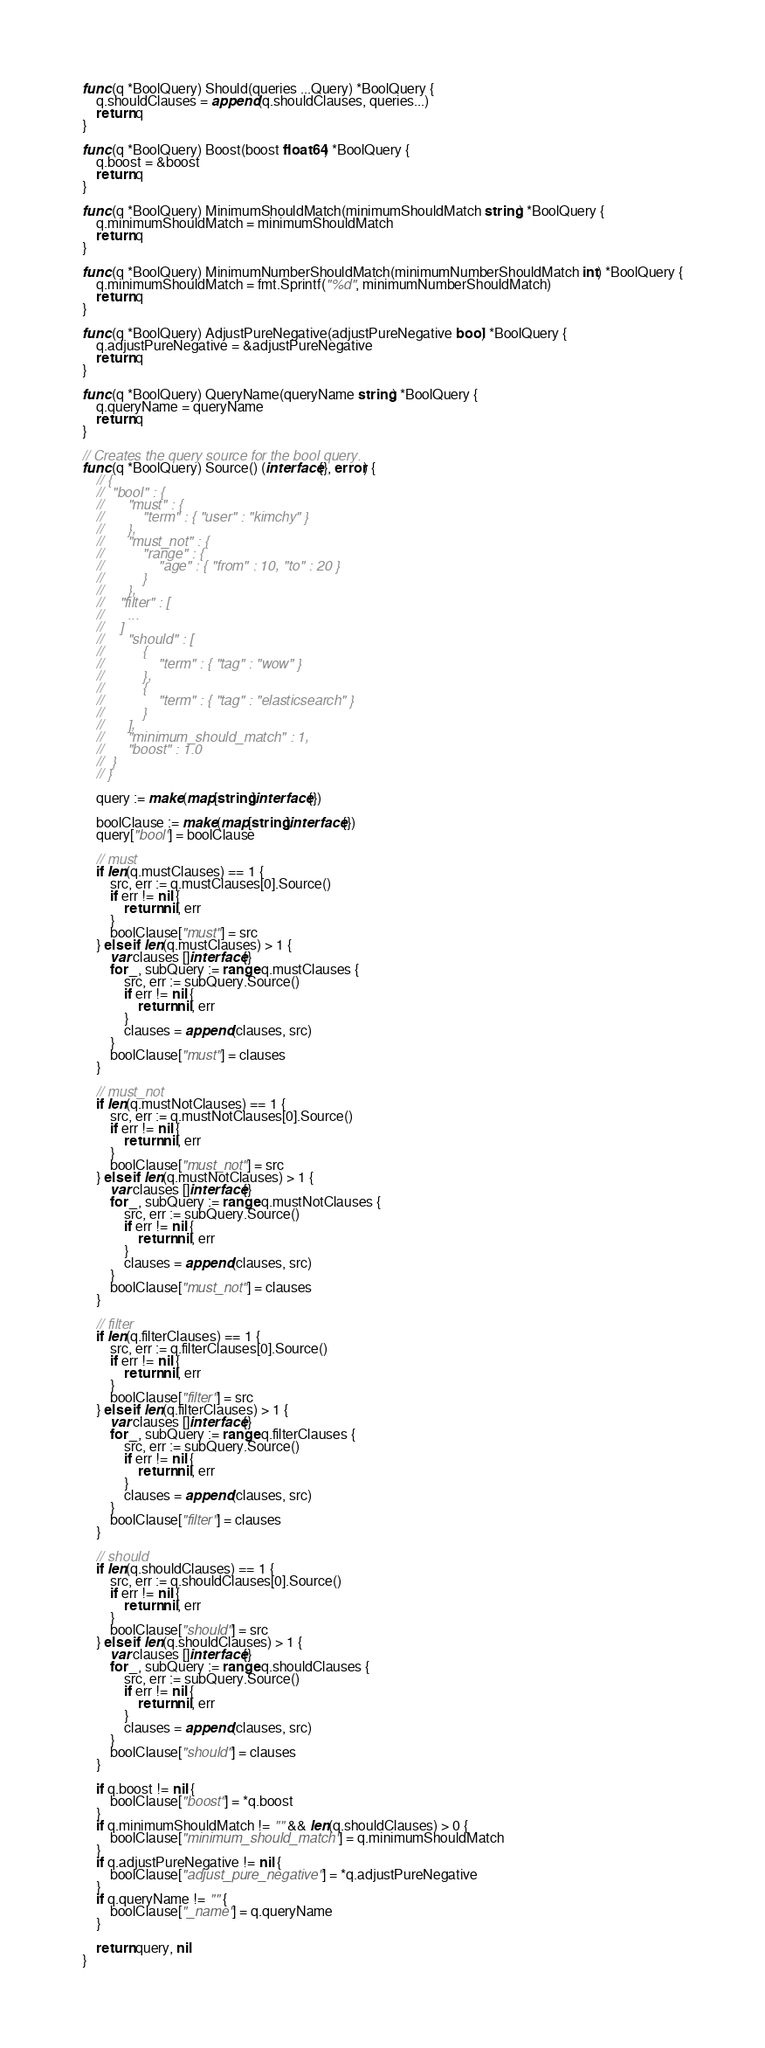<code> <loc_0><loc_0><loc_500><loc_500><_Go_>func (q *BoolQuery) Should(queries ...Query) *BoolQuery {
	q.shouldClauses = append(q.shouldClauses, queries...)
	return q
}

func (q *BoolQuery) Boost(boost float64) *BoolQuery {
	q.boost = &boost
	return q
}

func (q *BoolQuery) MinimumShouldMatch(minimumShouldMatch string) *BoolQuery {
	q.minimumShouldMatch = minimumShouldMatch
	return q
}

func (q *BoolQuery) MinimumNumberShouldMatch(minimumNumberShouldMatch int) *BoolQuery {
	q.minimumShouldMatch = fmt.Sprintf("%d", minimumNumberShouldMatch)
	return q
}

func (q *BoolQuery) AdjustPureNegative(adjustPureNegative bool) *BoolQuery {
	q.adjustPureNegative = &adjustPureNegative
	return q
}

func (q *BoolQuery) QueryName(queryName string) *BoolQuery {
	q.queryName = queryName
	return q
}

// Creates the query source for the bool query.
func (q *BoolQuery) Source() (interface{}, error) {
	// {
	//	"bool" : {
	//		"must" : {
	//			"term" : { "user" : "kimchy" }
	//		},
	//		"must_not" : {
	//			"range" : {
	//				"age" : { "from" : 10, "to" : 20 }
	//			}
	//		},
	//    "filter" : [
	//      ...
	//    ]
	//		"should" : [
	//			{
	//				"term" : { "tag" : "wow" }
	//			},
	//			{
	//				"term" : { "tag" : "elasticsearch" }
	//			}
	//		],
	//		"minimum_should_match" : 1,
	//		"boost" : 1.0
	//	}
	// }

	query := make(map[string]interface{})

	boolClause := make(map[string]interface{})
	query["bool"] = boolClause

	// must
	if len(q.mustClauses) == 1 {
		src, err := q.mustClauses[0].Source()
		if err != nil {
			return nil, err
		}
		boolClause["must"] = src
	} else if len(q.mustClauses) > 1 {
		var clauses []interface{}
		for _, subQuery := range q.mustClauses {
			src, err := subQuery.Source()
			if err != nil {
				return nil, err
			}
			clauses = append(clauses, src)
		}
		boolClause["must"] = clauses
	}

	// must_not
	if len(q.mustNotClauses) == 1 {
		src, err := q.mustNotClauses[0].Source()
		if err != nil {
			return nil, err
		}
		boolClause["must_not"] = src
	} else if len(q.mustNotClauses) > 1 {
		var clauses []interface{}
		for _, subQuery := range q.mustNotClauses {
			src, err := subQuery.Source()
			if err != nil {
				return nil, err
			}
			clauses = append(clauses, src)
		}
		boolClause["must_not"] = clauses
	}

	// filter
	if len(q.filterClauses) == 1 {
		src, err := q.filterClauses[0].Source()
		if err != nil {
			return nil, err
		}
		boolClause["filter"] = src
	} else if len(q.filterClauses) > 1 {
		var clauses []interface{}
		for _, subQuery := range q.filterClauses {
			src, err := subQuery.Source()
			if err != nil {
				return nil, err
			}
			clauses = append(clauses, src)
		}
		boolClause["filter"] = clauses
	}

	// should
	if len(q.shouldClauses) == 1 {
		src, err := q.shouldClauses[0].Source()
		if err != nil {
			return nil, err
		}
		boolClause["should"] = src
	} else if len(q.shouldClauses) > 1 {
		var clauses []interface{}
		for _, subQuery := range q.shouldClauses {
			src, err := subQuery.Source()
			if err != nil {
				return nil, err
			}
			clauses = append(clauses, src)
		}
		boolClause["should"] = clauses
	}

	if q.boost != nil {
		boolClause["boost"] = *q.boost
	}
	if q.minimumShouldMatch != "" && len(q.shouldClauses) > 0 {
		boolClause["minimum_should_match"] = q.minimumShouldMatch
	}
	if q.adjustPureNegative != nil {
		boolClause["adjust_pure_negative"] = *q.adjustPureNegative
	}
	if q.queryName != "" {
		boolClause["_name"] = q.queryName
	}

	return query, nil
}
</code> 